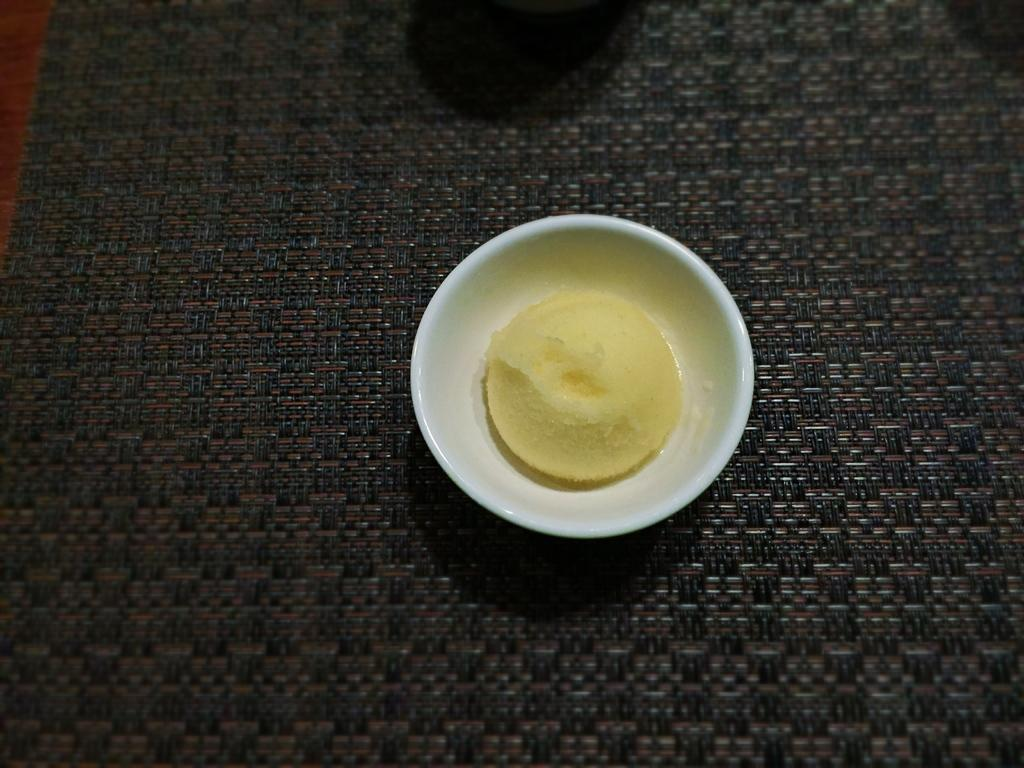What is the main subject in the image? There is an ice cream cup in the image. Where is the ice cream cup located? The ice cream cup is on a carpet. How many friends are visible in the image? There are no friends visible in the image; it only features an ice cream cup on a carpet. What type of thrill can be experienced by the ice cream cup in the image? The ice cream cup is an inanimate object and cannot experience any thrill. 